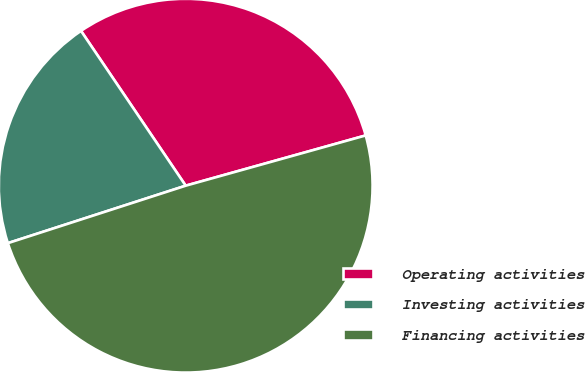<chart> <loc_0><loc_0><loc_500><loc_500><pie_chart><fcel>Operating activities<fcel>Investing activities<fcel>Financing activities<nl><fcel>30.13%<fcel>20.51%<fcel>49.36%<nl></chart> 